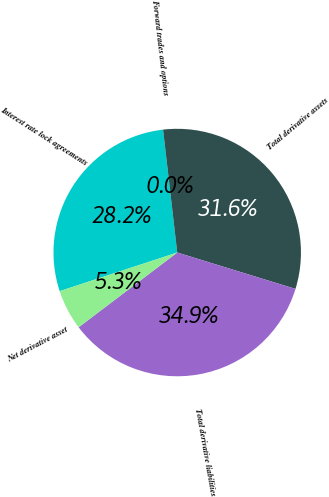Convert chart to OTSL. <chart><loc_0><loc_0><loc_500><loc_500><pie_chart><fcel>Interest rate lock agreements<fcel>Forward trades and options<fcel>Total derivative assets<fcel>Total derivative liabilities<fcel>Net derivative asset<nl><fcel>28.22%<fcel>0.0%<fcel>31.57%<fcel>34.92%<fcel>5.27%<nl></chart> 